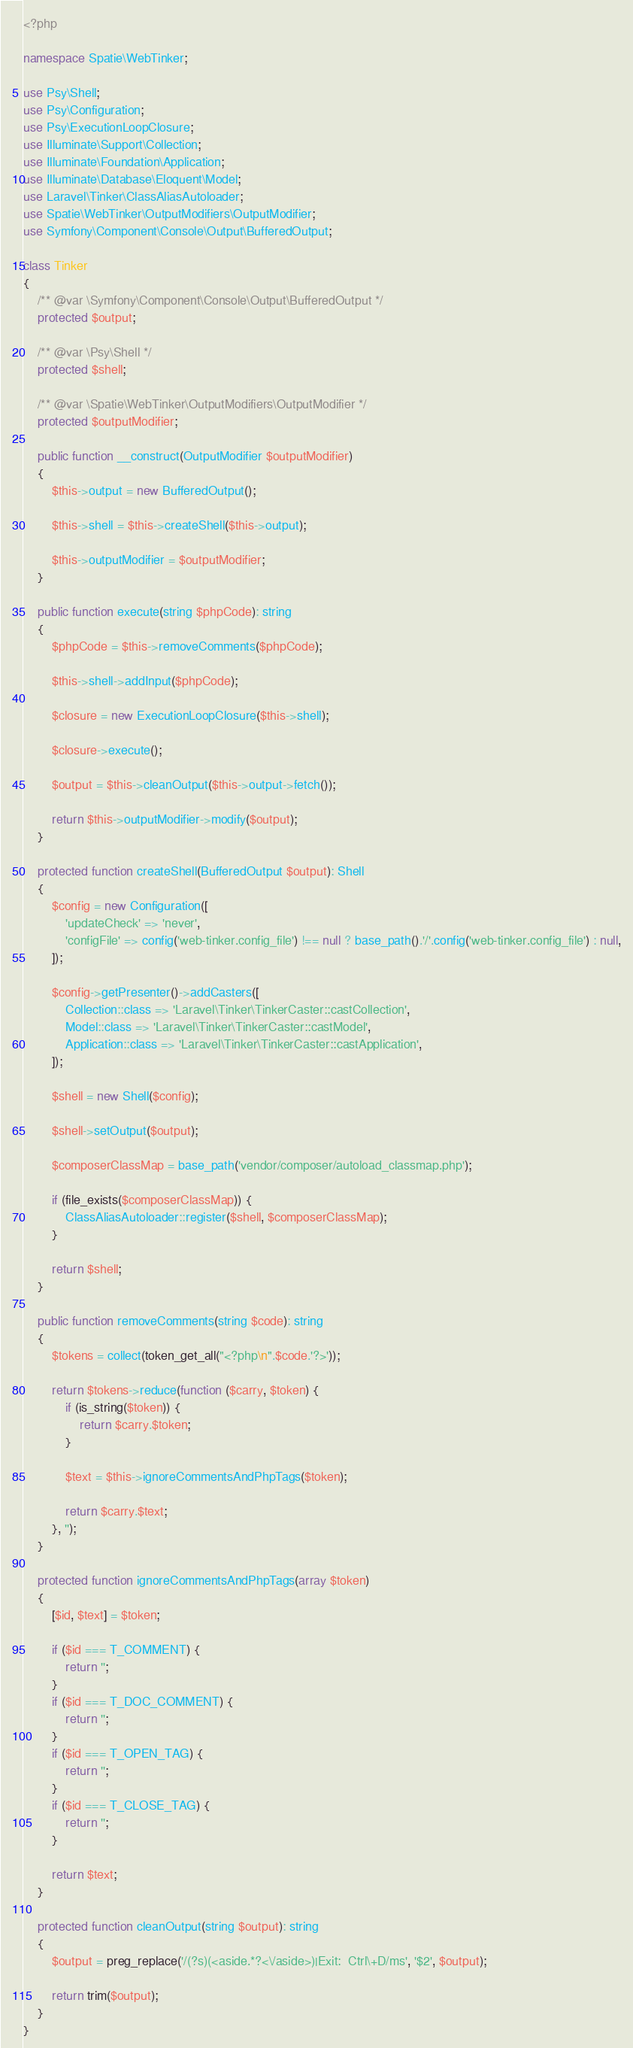<code> <loc_0><loc_0><loc_500><loc_500><_PHP_><?php

namespace Spatie\WebTinker;

use Psy\Shell;
use Psy\Configuration;
use Psy\ExecutionLoopClosure;
use Illuminate\Support\Collection;
use Illuminate\Foundation\Application;
use Illuminate\Database\Eloquent\Model;
use Laravel\Tinker\ClassAliasAutoloader;
use Spatie\WebTinker\OutputModifiers\OutputModifier;
use Symfony\Component\Console\Output\BufferedOutput;

class Tinker
{
    /** @var \Symfony\Component\Console\Output\BufferedOutput */
    protected $output;

    /** @var \Psy\Shell */
    protected $shell;

    /** @var \Spatie\WebTinker\OutputModifiers\OutputModifier */
    protected $outputModifier;

    public function __construct(OutputModifier $outputModifier)
    {
        $this->output = new BufferedOutput();

        $this->shell = $this->createShell($this->output);

        $this->outputModifier = $outputModifier;
    }

    public function execute(string $phpCode): string
    {
        $phpCode = $this->removeComments($phpCode);

        $this->shell->addInput($phpCode);

        $closure = new ExecutionLoopClosure($this->shell);

        $closure->execute();

        $output = $this->cleanOutput($this->output->fetch());

        return $this->outputModifier->modify($output);
    }

    protected function createShell(BufferedOutput $output): Shell
    {
        $config = new Configuration([
            'updateCheck' => 'never',
            'configFile' => config('web-tinker.config_file') !== null ? base_path().'/'.config('web-tinker.config_file') : null,
        ]);

        $config->getPresenter()->addCasters([
            Collection::class => 'Laravel\Tinker\TinkerCaster::castCollection',
            Model::class => 'Laravel\Tinker\TinkerCaster::castModel',
            Application::class => 'Laravel\Tinker\TinkerCaster::castApplication',
        ]);

        $shell = new Shell($config);

        $shell->setOutput($output);

        $composerClassMap = base_path('vendor/composer/autoload_classmap.php');

        if (file_exists($composerClassMap)) {
            ClassAliasAutoloader::register($shell, $composerClassMap);
        }

        return $shell;
    }

    public function removeComments(string $code): string
    {
        $tokens = collect(token_get_all("<?php\n".$code.'?>'));

        return $tokens->reduce(function ($carry, $token) {
            if (is_string($token)) {
                return $carry.$token;
            }

            $text = $this->ignoreCommentsAndPhpTags($token);

            return $carry.$text;
        }, '');
    }

    protected function ignoreCommentsAndPhpTags(array $token)
    {
        [$id, $text] = $token;

        if ($id === T_COMMENT) {
            return '';
        }
        if ($id === T_DOC_COMMENT) {
            return '';
        }
        if ($id === T_OPEN_TAG) {
            return '';
        }
        if ($id === T_CLOSE_TAG) {
            return '';
        }

        return $text;
    }

    protected function cleanOutput(string $output): string
    {
        $output = preg_replace('/(?s)(<aside.*?<\/aside>)|Exit:  Ctrl\+D/ms', '$2', $output);

        return trim($output);
    }
}
</code> 